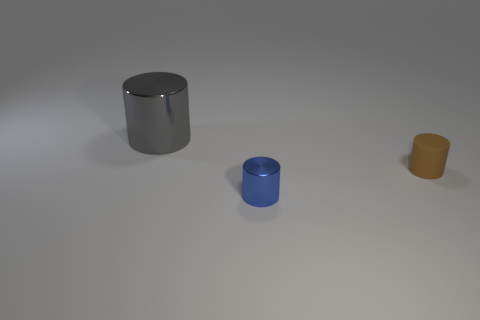Subtract all small brown cylinders. How many cylinders are left? 2 Subtract 2 cylinders. How many cylinders are left? 1 Subtract all purple spheres. How many gray cylinders are left? 1 Subtract all tiny blue shiny blocks. Subtract all large shiny things. How many objects are left? 2 Add 1 blue things. How many blue things are left? 2 Add 1 tiny metallic objects. How many tiny metallic objects exist? 2 Add 1 tiny yellow rubber objects. How many objects exist? 4 Subtract 1 blue cylinders. How many objects are left? 2 Subtract all purple cylinders. Subtract all blue spheres. How many cylinders are left? 3 